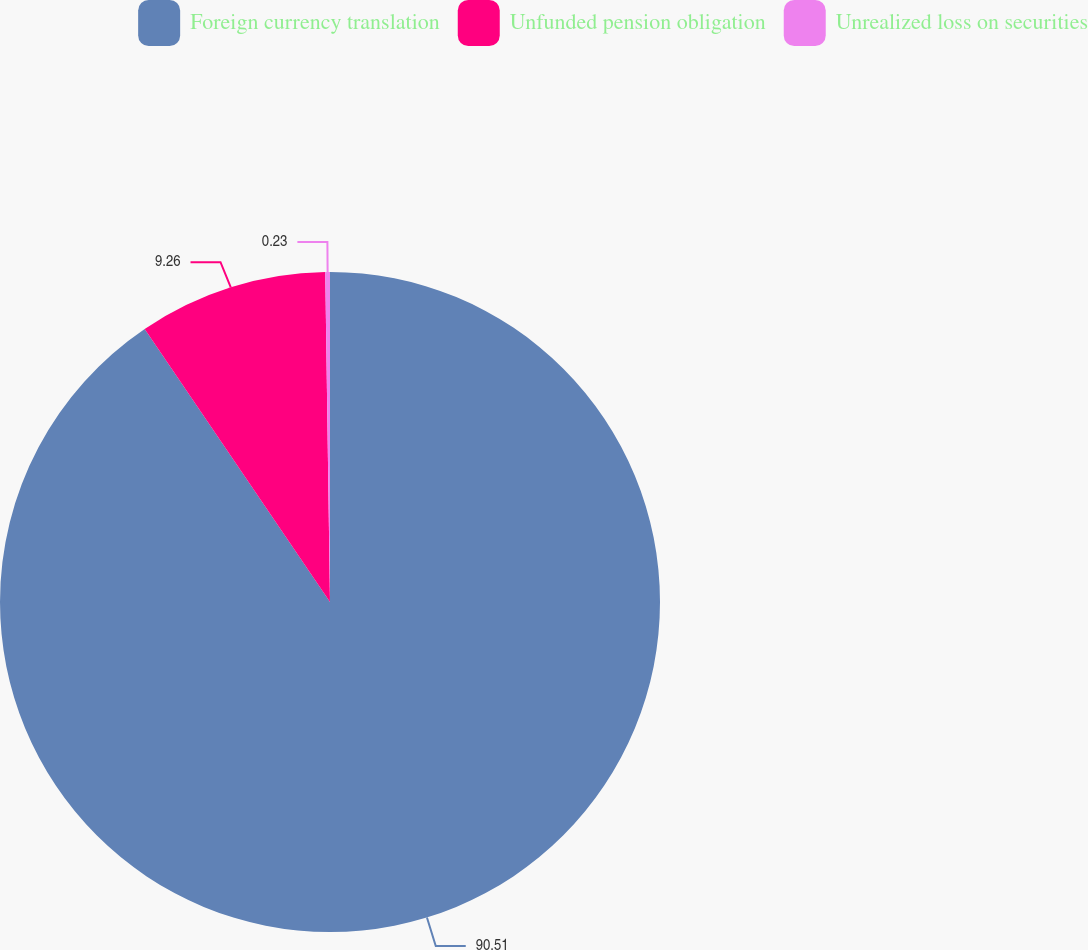<chart> <loc_0><loc_0><loc_500><loc_500><pie_chart><fcel>Foreign currency translation<fcel>Unfunded pension obligation<fcel>Unrealized loss on securities<nl><fcel>90.5%<fcel>9.26%<fcel>0.23%<nl></chart> 